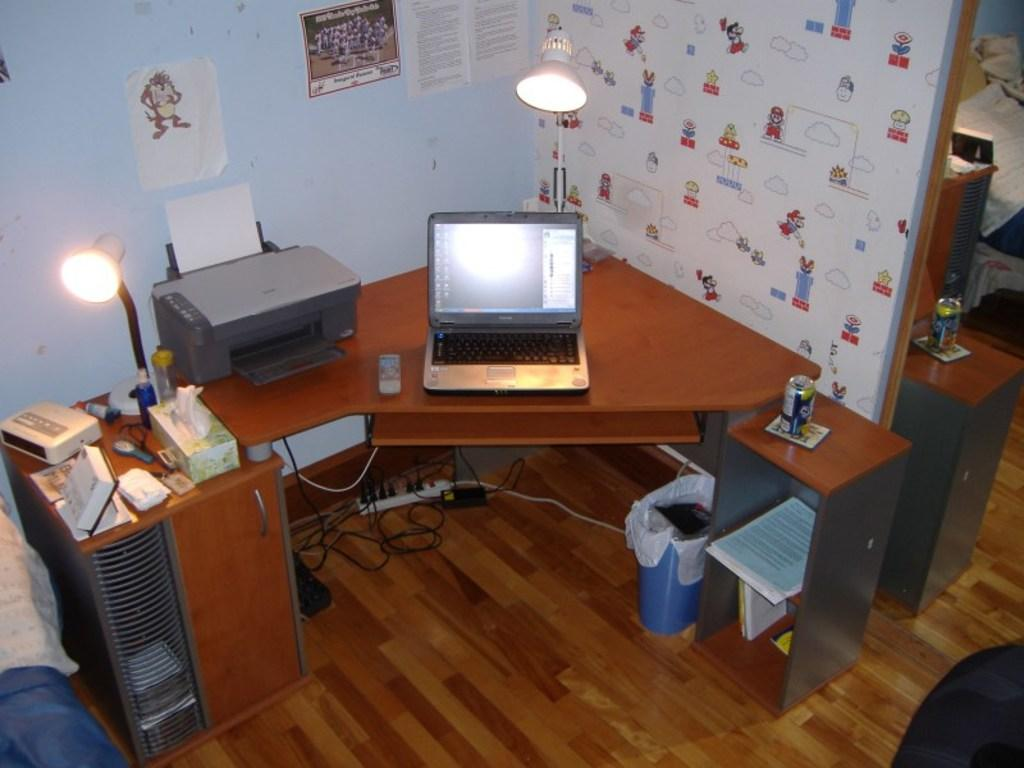What type of space is depicted in the image? There is a room in the image. What piece of furniture is in the room? There is a table in the room. What electronic device is on the table? A laptop is present on the table. What other office equipment is on the table? A printer is on the table. How many lights are on the table? There are two lights on the table. Are there any other items on the table? Yes, there are additional items on the table. What can be seen on the wall in the room? There are papers on the wall. What type of knee support is visible on the table? There is no knee support present in the image. Is there any toothpaste on the table? There is no toothpaste present in the image. 